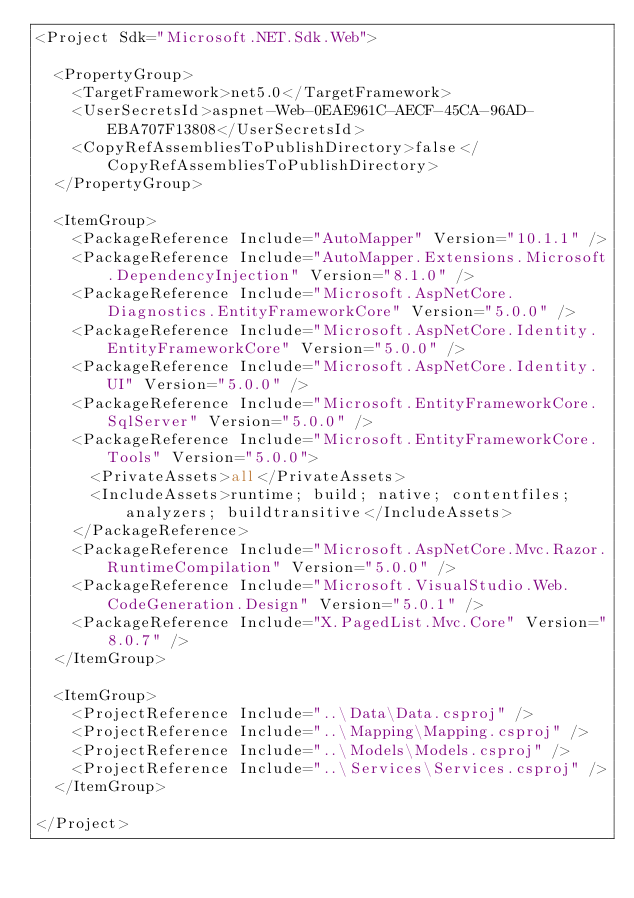Convert code to text. <code><loc_0><loc_0><loc_500><loc_500><_XML_><Project Sdk="Microsoft.NET.Sdk.Web">

	<PropertyGroup>
		<TargetFramework>net5.0</TargetFramework>
		<UserSecretsId>aspnet-Web-0EAE961C-AECF-45CA-96AD-EBA707F13808</UserSecretsId>
		<CopyRefAssembliesToPublishDirectory>false</CopyRefAssembliesToPublishDirectory>
	</PropertyGroup>

	<ItemGroup>
		<PackageReference Include="AutoMapper" Version="10.1.1" />
		<PackageReference Include="AutoMapper.Extensions.Microsoft.DependencyInjection" Version="8.1.0" />
		<PackageReference Include="Microsoft.AspNetCore.Diagnostics.EntityFrameworkCore" Version="5.0.0" />
		<PackageReference Include="Microsoft.AspNetCore.Identity.EntityFrameworkCore" Version="5.0.0" />
		<PackageReference Include="Microsoft.AspNetCore.Identity.UI" Version="5.0.0" />
		<PackageReference Include="Microsoft.EntityFrameworkCore.SqlServer" Version="5.0.0" />
		<PackageReference Include="Microsoft.EntityFrameworkCore.Tools" Version="5.0.0">
			<PrivateAssets>all</PrivateAssets>
			<IncludeAssets>runtime; build; native; contentfiles; analyzers; buildtransitive</IncludeAssets>
		</PackageReference>
		<PackageReference Include="Microsoft.AspNetCore.Mvc.Razor.RuntimeCompilation" Version="5.0.0" />
		<PackageReference Include="Microsoft.VisualStudio.Web.CodeGeneration.Design" Version="5.0.1" />
		<PackageReference Include="X.PagedList.Mvc.Core" Version="8.0.7" />
	</ItemGroup>

	<ItemGroup>
		<ProjectReference Include="..\Data\Data.csproj" />
		<ProjectReference Include="..\Mapping\Mapping.csproj" />
		<ProjectReference Include="..\Models\Models.csproj" />
		<ProjectReference Include="..\Services\Services.csproj" />
	</ItemGroup>

</Project>
</code> 